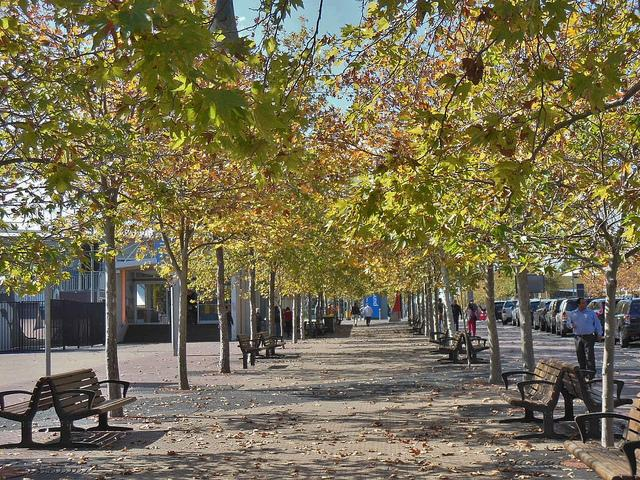What season of the year is it?

Choices:
A) winter
B) summer
C) spring
D) autumn autumn 